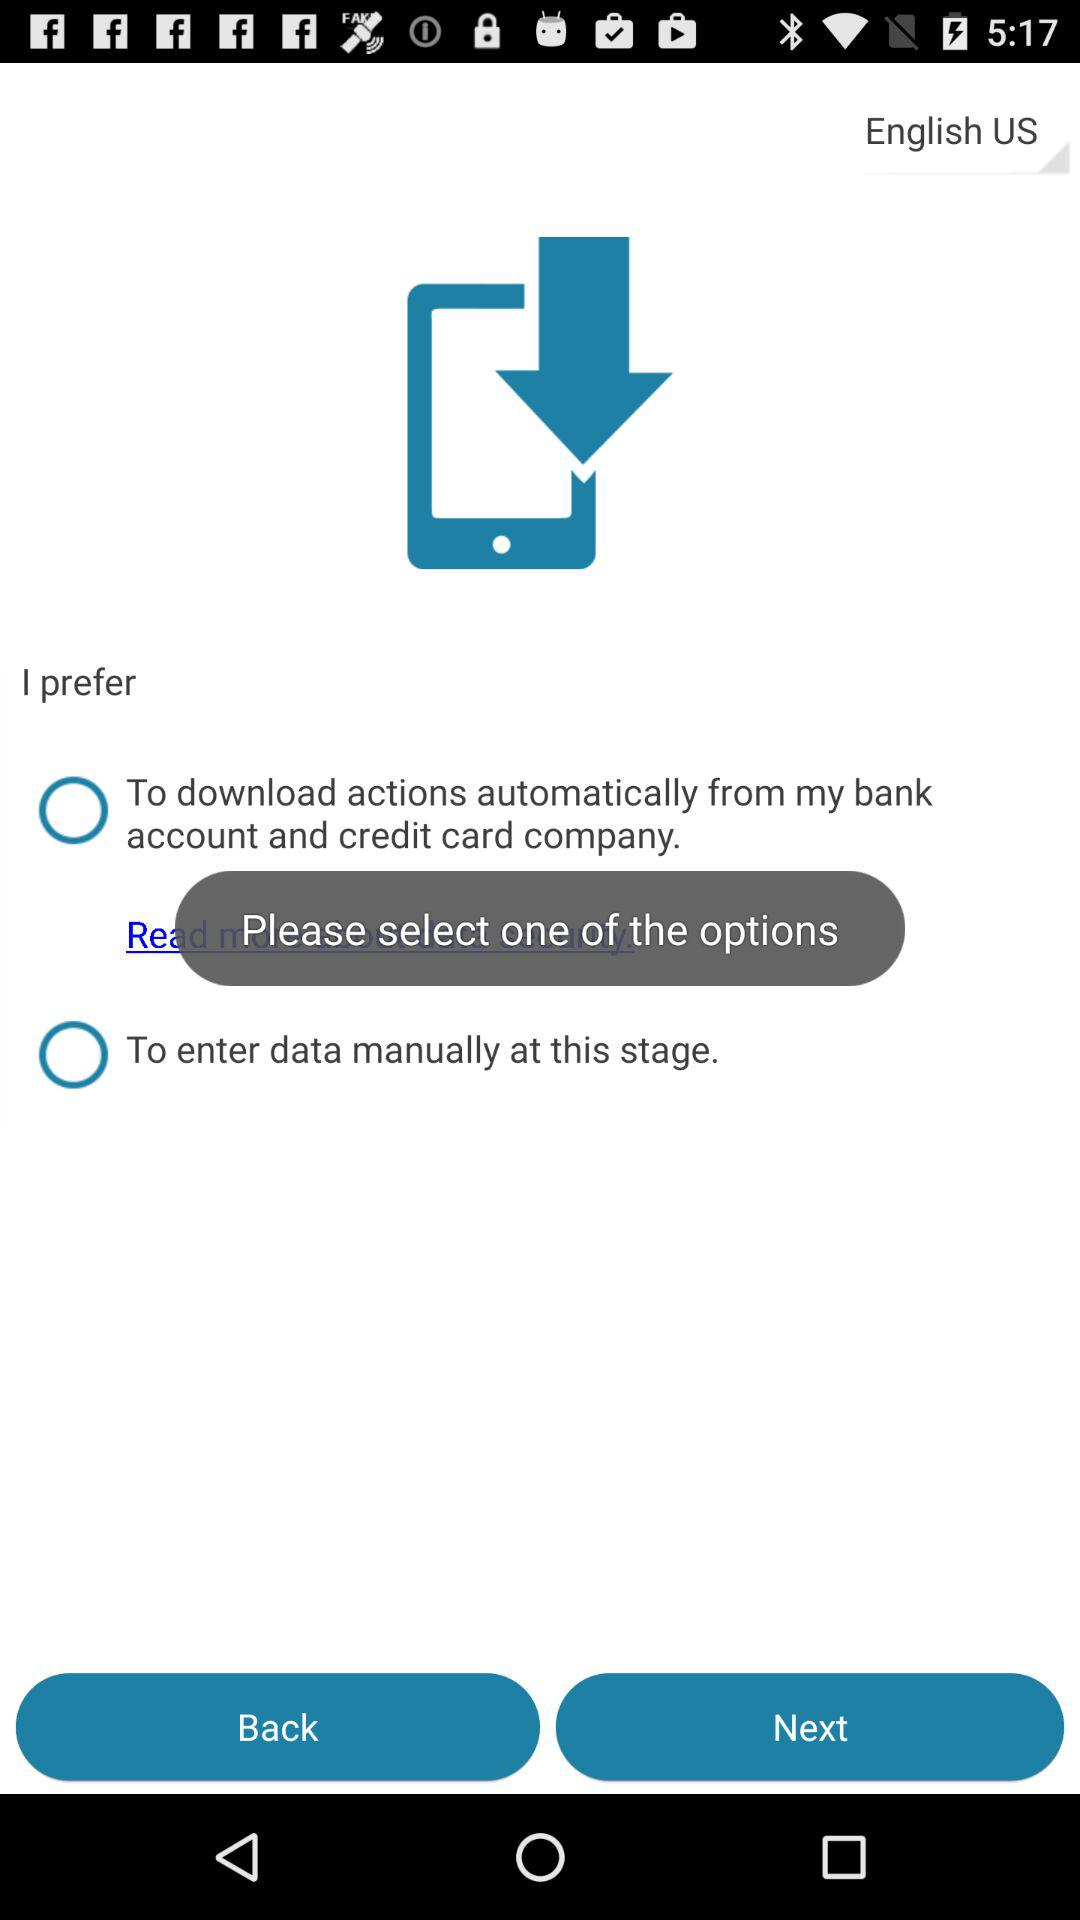How many options are there for how the data is entered?
Answer the question using a single word or phrase. 2 